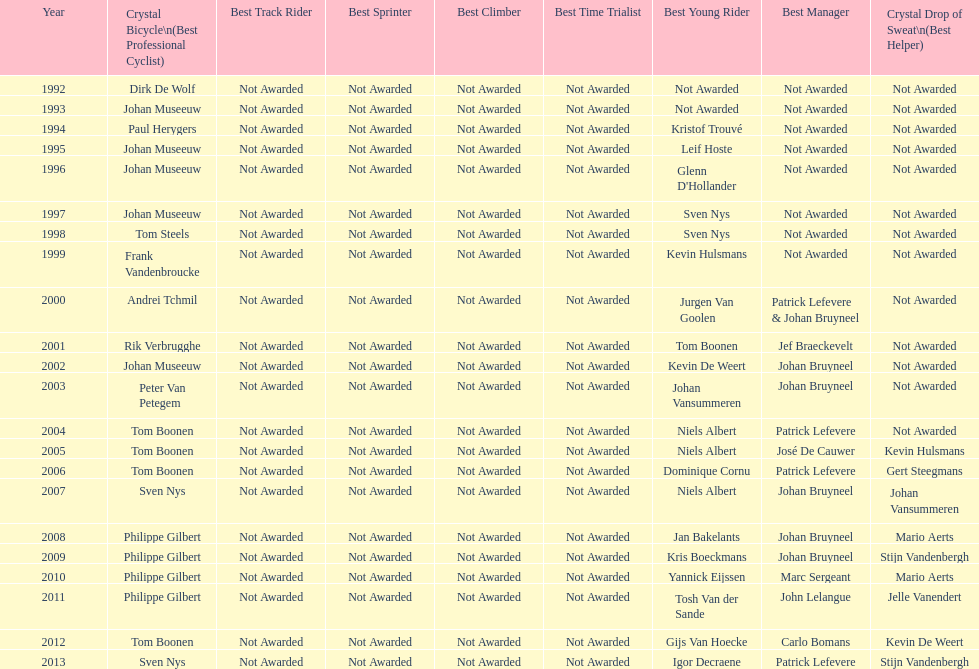Who won the most consecutive crystal bicycles? Philippe Gilbert. Can you parse all the data within this table? {'header': ['Year', 'Crystal Bicycle\\n(Best Professional Cyclist)', 'Best Track Rider', 'Best Sprinter', 'Best Climber', 'Best Time Trialist', 'Best Young Rider', 'Best Manager', 'Crystal Drop of Sweat\\n(Best Helper)'], 'rows': [['1992', 'Dirk De Wolf', 'Not Awarded', 'Not Awarded', 'Not Awarded', 'Not Awarded', 'Not Awarded', 'Not Awarded', 'Not Awarded'], ['1993', 'Johan Museeuw', 'Not Awarded', 'Not Awarded', 'Not Awarded', 'Not Awarded', 'Not Awarded', 'Not Awarded', 'Not Awarded'], ['1994', 'Paul Herygers', 'Not Awarded', 'Not Awarded', 'Not Awarded', 'Not Awarded', 'Kristof Trouvé', 'Not Awarded', 'Not Awarded'], ['1995', 'Johan Museeuw', 'Not Awarded', 'Not Awarded', 'Not Awarded', 'Not Awarded', 'Leif Hoste', 'Not Awarded', 'Not Awarded'], ['1996', 'Johan Museeuw', 'Not Awarded', 'Not Awarded', 'Not Awarded', 'Not Awarded', "Glenn D'Hollander", 'Not Awarded', 'Not Awarded'], ['1997', 'Johan Museeuw', 'Not Awarded', 'Not Awarded', 'Not Awarded', 'Not Awarded', 'Sven Nys', 'Not Awarded', 'Not Awarded'], ['1998', 'Tom Steels', 'Not Awarded', 'Not Awarded', 'Not Awarded', 'Not Awarded', 'Sven Nys', 'Not Awarded', 'Not Awarded'], ['1999', 'Frank Vandenbroucke', 'Not Awarded', 'Not Awarded', 'Not Awarded', 'Not Awarded', 'Kevin Hulsmans', 'Not Awarded', 'Not Awarded'], ['2000', 'Andrei Tchmil', 'Not Awarded', 'Not Awarded', 'Not Awarded', 'Not Awarded', 'Jurgen Van Goolen', 'Patrick Lefevere & Johan Bruyneel', 'Not Awarded'], ['2001', 'Rik Verbrugghe', 'Not Awarded', 'Not Awarded', 'Not Awarded', 'Not Awarded', 'Tom Boonen', 'Jef Braeckevelt', 'Not Awarded'], ['2002', 'Johan Museeuw', 'Not Awarded', 'Not Awarded', 'Not Awarded', 'Not Awarded', 'Kevin De Weert', 'Johan Bruyneel', 'Not Awarded'], ['2003', 'Peter Van Petegem', 'Not Awarded', 'Not Awarded', 'Not Awarded', 'Not Awarded', 'Johan Vansummeren', 'Johan Bruyneel', 'Not Awarded'], ['2004', 'Tom Boonen', 'Not Awarded', 'Not Awarded', 'Not Awarded', 'Not Awarded', 'Niels Albert', 'Patrick Lefevere', 'Not Awarded'], ['2005', 'Tom Boonen', 'Not Awarded', 'Not Awarded', 'Not Awarded', 'Not Awarded', 'Niels Albert', 'José De Cauwer', 'Kevin Hulsmans'], ['2006', 'Tom Boonen', 'Not Awarded', 'Not Awarded', 'Not Awarded', 'Not Awarded', 'Dominique Cornu', 'Patrick Lefevere', 'Gert Steegmans'], ['2007', 'Sven Nys', 'Not Awarded', 'Not Awarded', 'Not Awarded', 'Not Awarded', 'Niels Albert', 'Johan Bruyneel', 'Johan Vansummeren'], ['2008', 'Philippe Gilbert', 'Not Awarded', 'Not Awarded', 'Not Awarded', 'Not Awarded', 'Jan Bakelants', 'Johan Bruyneel', 'Mario Aerts'], ['2009', 'Philippe Gilbert', 'Not Awarded', 'Not Awarded', 'Not Awarded', 'Not Awarded', 'Kris Boeckmans', 'Johan Bruyneel', 'Stijn Vandenbergh'], ['2010', 'Philippe Gilbert', 'Not Awarded', 'Not Awarded', 'Not Awarded', 'Not Awarded', 'Yannick Eijssen', 'Marc Sergeant', 'Mario Aerts'], ['2011', 'Philippe Gilbert', 'Not Awarded', 'Not Awarded', 'Not Awarded', 'Not Awarded', 'Tosh Van der Sande', 'John Lelangue', 'Jelle Vanendert'], ['2012', 'Tom Boonen', 'Not Awarded', 'Not Awarded', 'Not Awarded', 'Not Awarded', 'Gijs Van Hoecke', 'Carlo Bomans', 'Kevin De Weert'], ['2013', 'Sven Nys', 'Not Awarded', 'Not Awarded', 'Not Awarded', 'Not Awarded', 'Igor Decraene', 'Patrick Lefevere', 'Stijn Vandenbergh']]} 